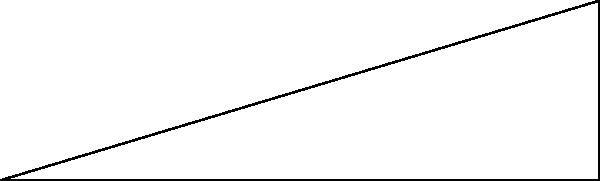You want to design a new bread cooling rack for your artisan bakery. To ensure even airflow, you decide to create an inclined surface. If the rack is 10 cm long and elevated 3 cm at one end, what is the angle of inclination ($x$) in degrees? To find the angle of inclination, we can use trigonometry. Let's approach this step-by-step:

1) We have a right-angled triangle where:
   - The base (adjacent side) is 10 cm
   - The height (opposite side) is 3 cm
   - We need to find the angle $x$

2) In a right-angled triangle, tangent of an angle is the ratio of the opposite side to the adjacent side:

   $\tan(x) = \frac{\text{opposite}}{\text{adjacent}} = \frac{3}{10} = 0.3$

3) To find the angle, we need to use the inverse tangent (arctan or $\tan^{-1}$):

   $x = \tan^{-1}(0.3)$

4) Using a calculator or trigonometric tables:

   $x \approx 16.70^\circ$

5) Rounding to the nearest degree:

   $x \approx 17^\circ$

Therefore, the angle of inclination for the bread cooling rack is approximately 17 degrees.
Answer: $17^\circ$ 